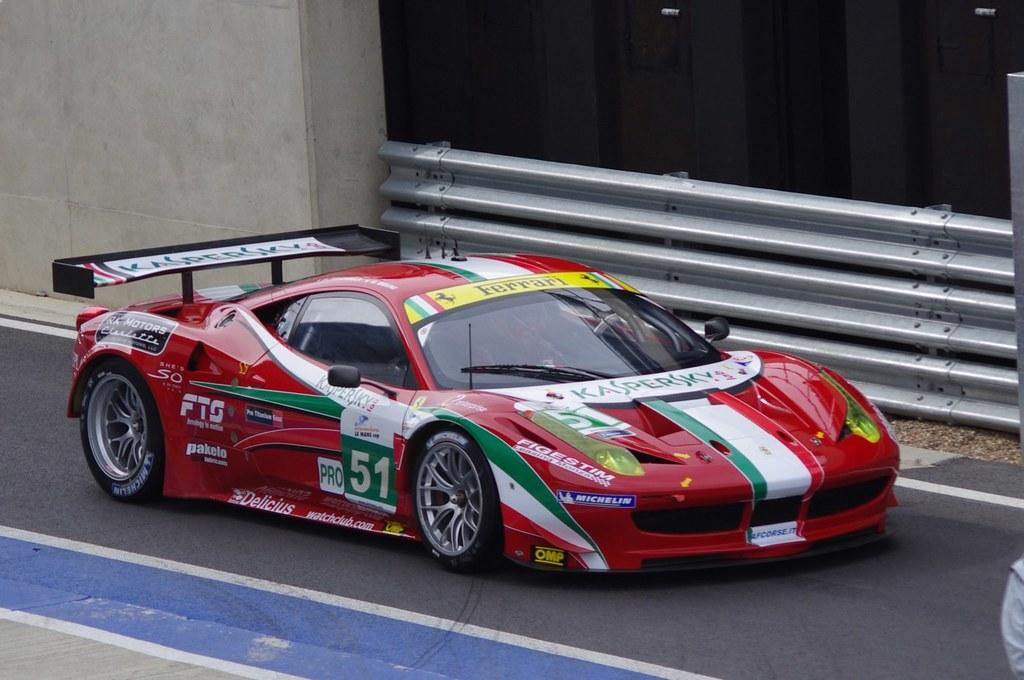What is the main subject of the image? There is a car on the road in the image. What can be seen in the background of the image? There is a wall and a railing in the background of the image. What type of produce is being sold on the street in the image? There is no produce or street present in the image; it features a car on the road with a wall and a railing in the background. 